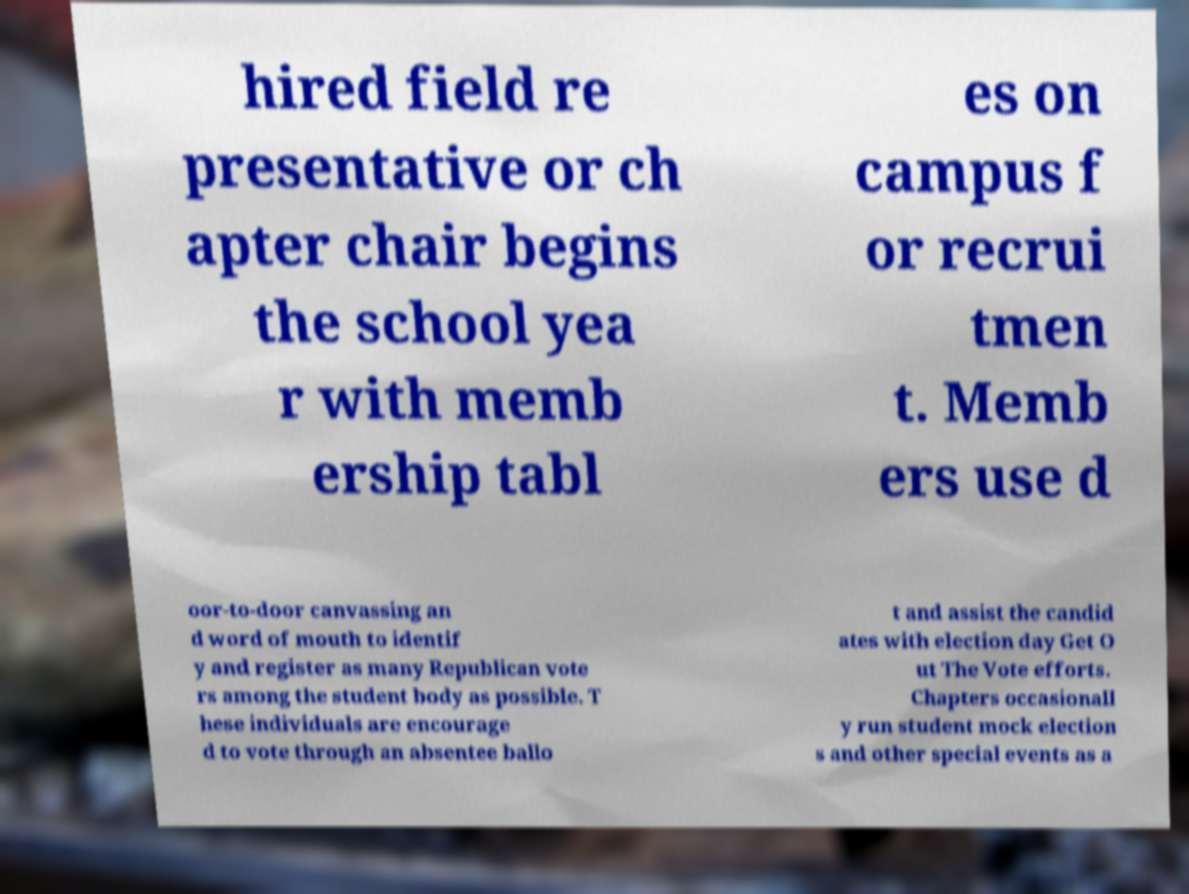Please identify and transcribe the text found in this image. hired field re presentative or ch apter chair begins the school yea r with memb ership tabl es on campus f or recrui tmen t. Memb ers use d oor-to-door canvassing an d word of mouth to identif y and register as many Republican vote rs among the student body as possible. T hese individuals are encourage d to vote through an absentee ballo t and assist the candid ates with election day Get O ut The Vote efforts. Chapters occasionall y run student mock election s and other special events as a 